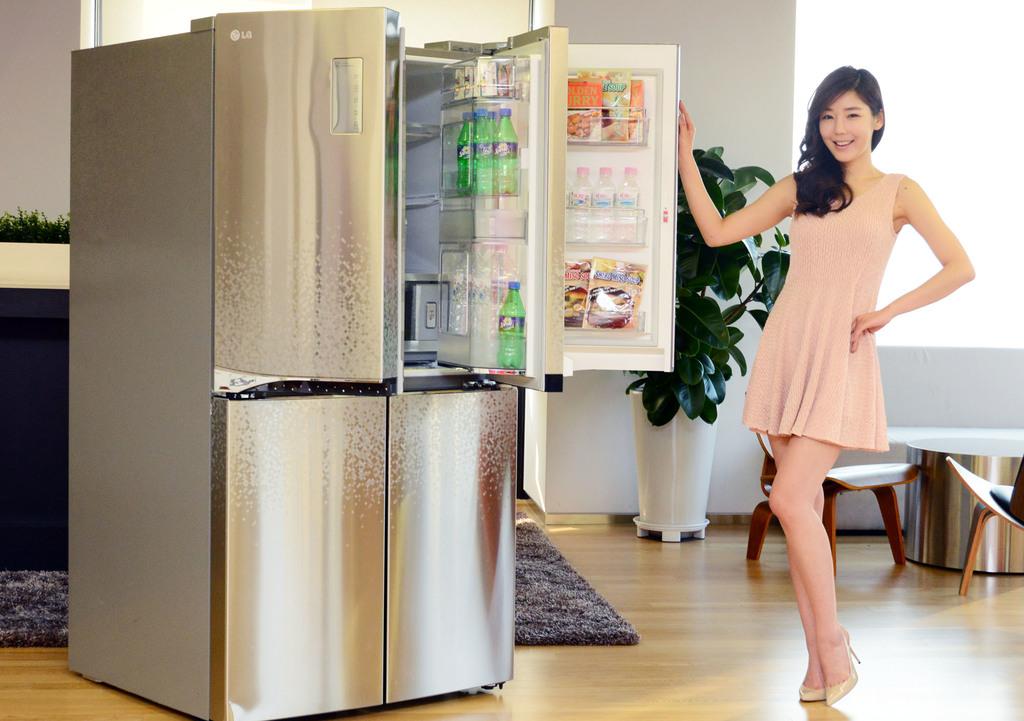What is the brand of refrigerator?
Your answer should be very brief. Lg. What is the brand of soda in the refigerator?
Keep it short and to the point. Sprite. 